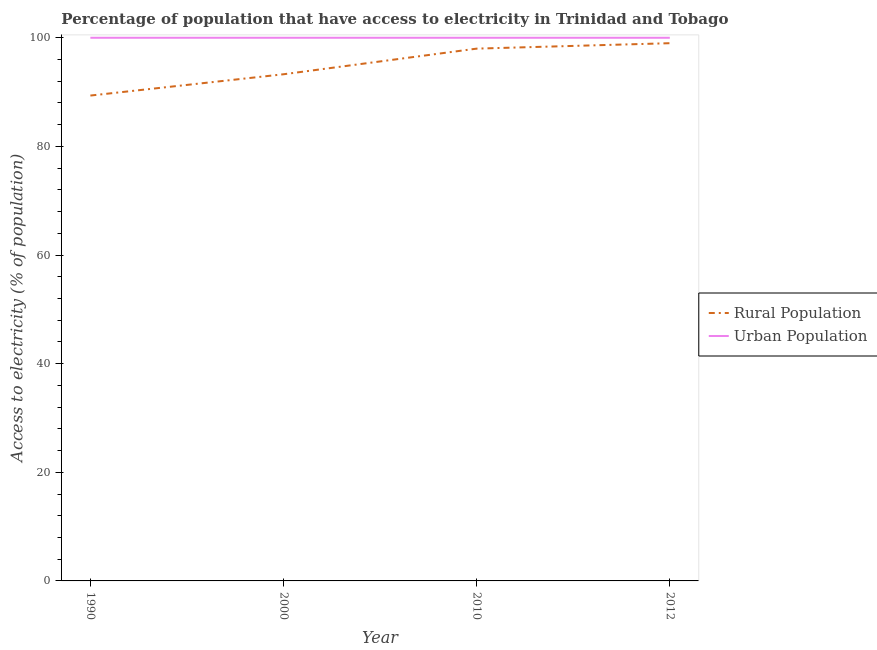What is the percentage of urban population having access to electricity in 2010?
Provide a succinct answer. 100. Across all years, what is the maximum percentage of rural population having access to electricity?
Offer a terse response. 99. Across all years, what is the minimum percentage of rural population having access to electricity?
Keep it short and to the point. 89.36. What is the total percentage of urban population having access to electricity in the graph?
Your answer should be very brief. 400. What is the difference between the percentage of rural population having access to electricity in 2000 and that in 2012?
Your answer should be compact. -5.72. What is the difference between the percentage of urban population having access to electricity in 2010 and the percentage of rural population having access to electricity in 2000?
Your answer should be compact. 6.72. What is the average percentage of urban population having access to electricity per year?
Provide a short and direct response. 100. In the year 1990, what is the difference between the percentage of rural population having access to electricity and percentage of urban population having access to electricity?
Give a very brief answer. -10.64. What is the ratio of the percentage of rural population having access to electricity in 2000 to that in 2010?
Provide a succinct answer. 0.95. Is the percentage of urban population having access to electricity in 1990 less than that in 2012?
Your answer should be very brief. No. Is the difference between the percentage of urban population having access to electricity in 1990 and 2010 greater than the difference between the percentage of rural population having access to electricity in 1990 and 2010?
Provide a short and direct response. Yes. What is the difference between the highest and the lowest percentage of rural population having access to electricity?
Your answer should be very brief. 9.64. Is the percentage of rural population having access to electricity strictly less than the percentage of urban population having access to electricity over the years?
Make the answer very short. Yes. What is the difference between two consecutive major ticks on the Y-axis?
Keep it short and to the point. 20. Does the graph contain any zero values?
Make the answer very short. No. Does the graph contain grids?
Offer a terse response. No. How many legend labels are there?
Make the answer very short. 2. What is the title of the graph?
Make the answer very short. Percentage of population that have access to electricity in Trinidad and Tobago. What is the label or title of the Y-axis?
Keep it short and to the point. Access to electricity (% of population). What is the Access to electricity (% of population) in Rural Population in 1990?
Your response must be concise. 89.36. What is the Access to electricity (% of population) of Urban Population in 1990?
Your answer should be very brief. 100. What is the Access to electricity (% of population) of Rural Population in 2000?
Your response must be concise. 93.28. What is the Access to electricity (% of population) in Urban Population in 2000?
Keep it short and to the point. 100. What is the Access to electricity (% of population) of Urban Population in 2010?
Give a very brief answer. 100. What is the Access to electricity (% of population) in Urban Population in 2012?
Your answer should be very brief. 100. Across all years, what is the minimum Access to electricity (% of population) of Rural Population?
Make the answer very short. 89.36. Across all years, what is the minimum Access to electricity (% of population) of Urban Population?
Keep it short and to the point. 100. What is the total Access to electricity (% of population) in Rural Population in the graph?
Offer a very short reply. 379.64. What is the total Access to electricity (% of population) in Urban Population in the graph?
Your answer should be compact. 400. What is the difference between the Access to electricity (% of population) in Rural Population in 1990 and that in 2000?
Give a very brief answer. -3.92. What is the difference between the Access to electricity (% of population) of Rural Population in 1990 and that in 2010?
Give a very brief answer. -8.64. What is the difference between the Access to electricity (% of population) of Rural Population in 1990 and that in 2012?
Offer a very short reply. -9.64. What is the difference between the Access to electricity (% of population) in Rural Population in 2000 and that in 2010?
Offer a very short reply. -4.72. What is the difference between the Access to electricity (% of population) of Rural Population in 2000 and that in 2012?
Offer a very short reply. -5.72. What is the difference between the Access to electricity (% of population) in Urban Population in 2000 and that in 2012?
Ensure brevity in your answer.  0. What is the difference between the Access to electricity (% of population) of Urban Population in 2010 and that in 2012?
Offer a very short reply. 0. What is the difference between the Access to electricity (% of population) in Rural Population in 1990 and the Access to electricity (% of population) in Urban Population in 2000?
Provide a succinct answer. -10.64. What is the difference between the Access to electricity (% of population) of Rural Population in 1990 and the Access to electricity (% of population) of Urban Population in 2010?
Keep it short and to the point. -10.64. What is the difference between the Access to electricity (% of population) in Rural Population in 1990 and the Access to electricity (% of population) in Urban Population in 2012?
Your response must be concise. -10.64. What is the difference between the Access to electricity (% of population) of Rural Population in 2000 and the Access to electricity (% of population) of Urban Population in 2010?
Make the answer very short. -6.72. What is the difference between the Access to electricity (% of population) in Rural Population in 2000 and the Access to electricity (% of population) in Urban Population in 2012?
Ensure brevity in your answer.  -6.72. What is the average Access to electricity (% of population) of Rural Population per year?
Keep it short and to the point. 94.91. In the year 1990, what is the difference between the Access to electricity (% of population) of Rural Population and Access to electricity (% of population) of Urban Population?
Offer a terse response. -10.64. In the year 2000, what is the difference between the Access to electricity (% of population) of Rural Population and Access to electricity (% of population) of Urban Population?
Offer a terse response. -6.72. What is the ratio of the Access to electricity (% of population) of Rural Population in 1990 to that in 2000?
Provide a short and direct response. 0.96. What is the ratio of the Access to electricity (% of population) in Rural Population in 1990 to that in 2010?
Give a very brief answer. 0.91. What is the ratio of the Access to electricity (% of population) of Urban Population in 1990 to that in 2010?
Make the answer very short. 1. What is the ratio of the Access to electricity (% of population) of Rural Population in 1990 to that in 2012?
Your answer should be very brief. 0.9. What is the ratio of the Access to electricity (% of population) of Urban Population in 1990 to that in 2012?
Provide a short and direct response. 1. What is the ratio of the Access to electricity (% of population) in Rural Population in 2000 to that in 2010?
Make the answer very short. 0.95. What is the ratio of the Access to electricity (% of population) in Urban Population in 2000 to that in 2010?
Make the answer very short. 1. What is the ratio of the Access to electricity (% of population) of Rural Population in 2000 to that in 2012?
Your answer should be compact. 0.94. What is the ratio of the Access to electricity (% of population) of Urban Population in 2010 to that in 2012?
Provide a succinct answer. 1. What is the difference between the highest and the second highest Access to electricity (% of population) in Rural Population?
Provide a succinct answer. 1. What is the difference between the highest and the lowest Access to electricity (% of population) of Rural Population?
Your response must be concise. 9.64. What is the difference between the highest and the lowest Access to electricity (% of population) of Urban Population?
Offer a terse response. 0. 